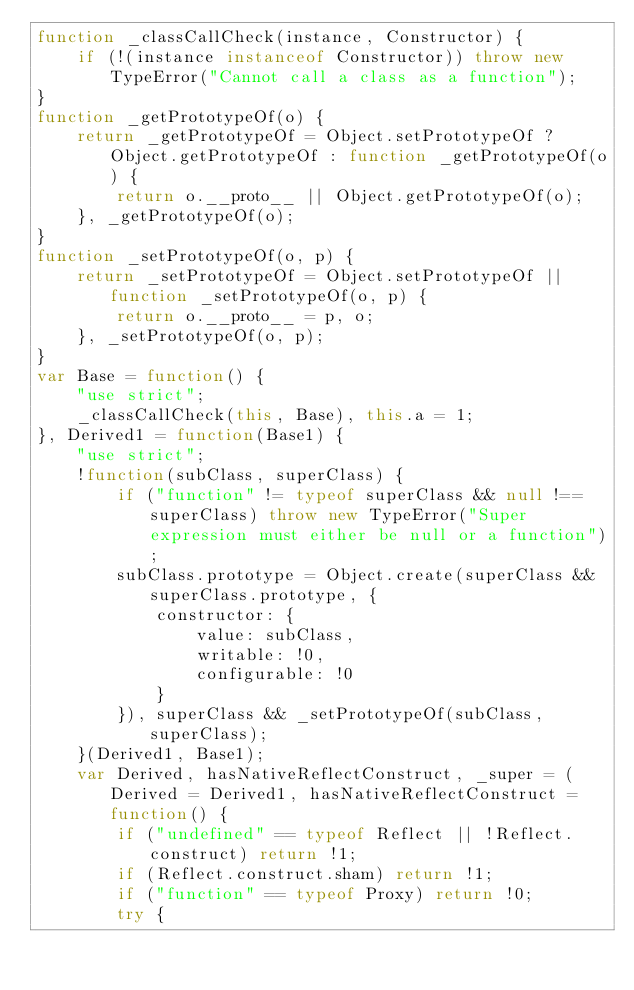Convert code to text. <code><loc_0><loc_0><loc_500><loc_500><_JavaScript_>function _classCallCheck(instance, Constructor) {
    if (!(instance instanceof Constructor)) throw new TypeError("Cannot call a class as a function");
}
function _getPrototypeOf(o) {
    return _getPrototypeOf = Object.setPrototypeOf ? Object.getPrototypeOf : function _getPrototypeOf(o) {
        return o.__proto__ || Object.getPrototypeOf(o);
    }, _getPrototypeOf(o);
}
function _setPrototypeOf(o, p) {
    return _setPrototypeOf = Object.setPrototypeOf || function _setPrototypeOf(o, p) {
        return o.__proto__ = p, o;
    }, _setPrototypeOf(o, p);
}
var Base = function() {
    "use strict";
    _classCallCheck(this, Base), this.a = 1;
}, Derived1 = function(Base1) {
    "use strict";
    !function(subClass, superClass) {
        if ("function" != typeof superClass && null !== superClass) throw new TypeError("Super expression must either be null or a function");
        subClass.prototype = Object.create(superClass && superClass.prototype, {
            constructor: {
                value: subClass,
                writable: !0,
                configurable: !0
            }
        }), superClass && _setPrototypeOf(subClass, superClass);
    }(Derived1, Base1);
    var Derived, hasNativeReflectConstruct, _super = (Derived = Derived1, hasNativeReflectConstruct = function() {
        if ("undefined" == typeof Reflect || !Reflect.construct) return !1;
        if (Reflect.construct.sham) return !1;
        if ("function" == typeof Proxy) return !0;
        try {</code> 